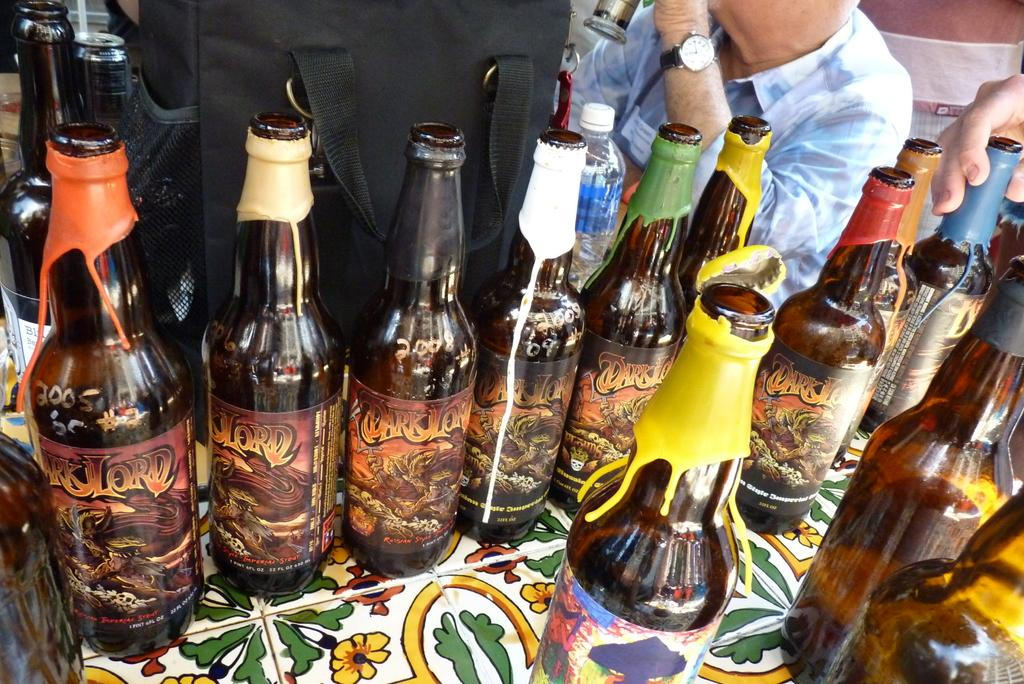<image>
Give a short and clear explanation of the subsequent image. Bottles of Dark Lord beer with colorful wax seals 